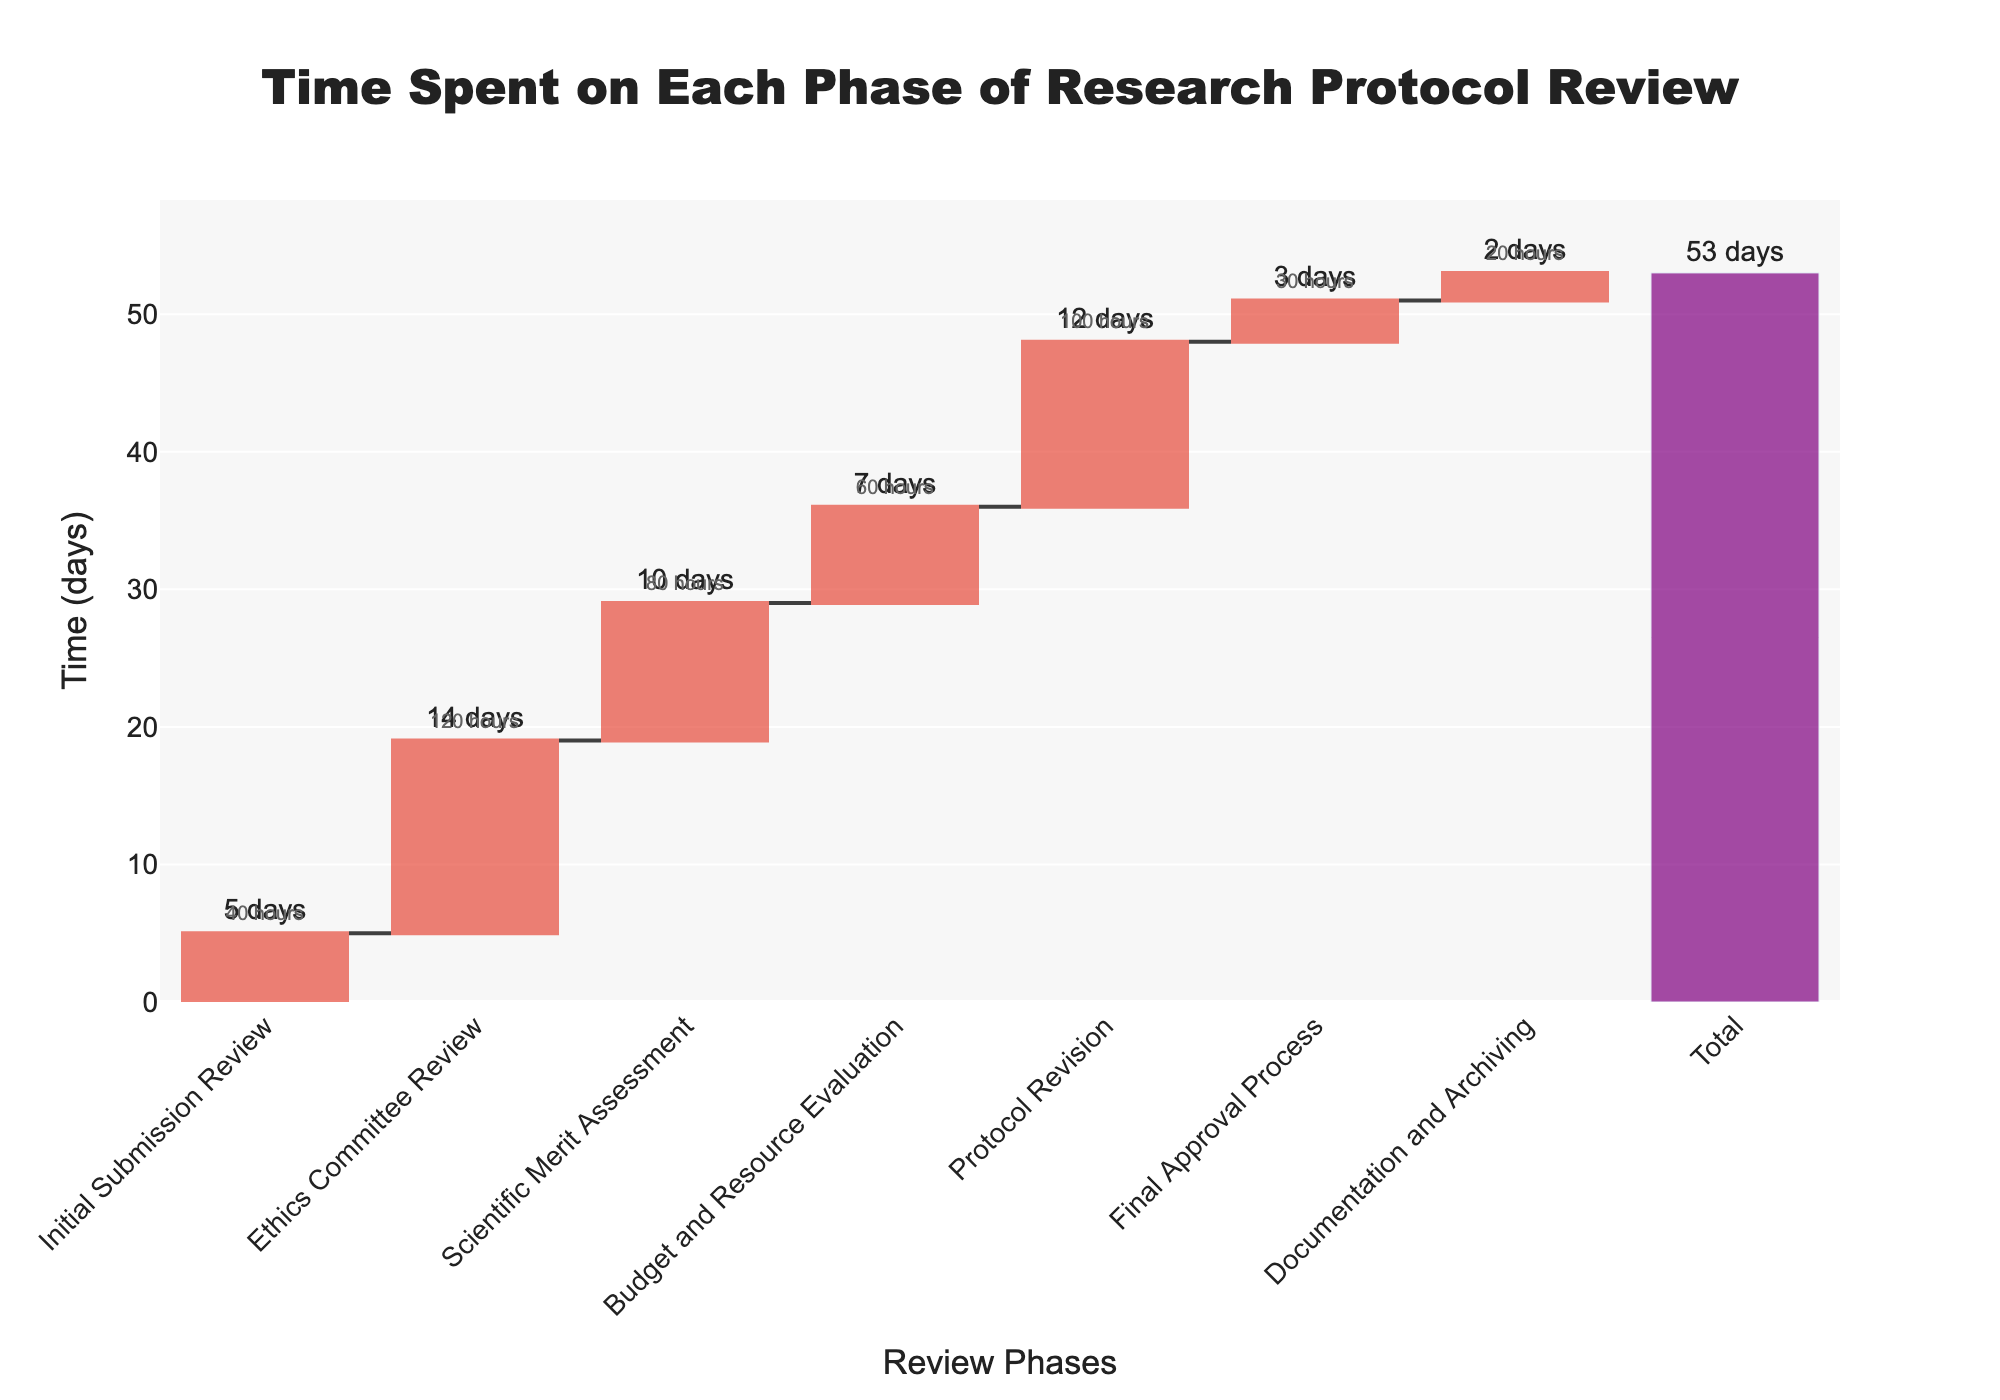what is the total time spent on the entire research protocol review process? The waterfall chart includes an extra bar at the end labeled "Total." This bar represents the sum of all times spent on individual phases. By looking at this bar, we can see that the total time spent is 53 days.
Answer: 53 days how much time is spent on the initial submission review phase? In the waterfall chart, each phase of the review process is labeled along the x-axis, and the corresponding time spent is indicated above each bar. For the "Initial Submission Review" phase, the label shows that 5 days were spent.
Answer: 5 days which phase required the highest number of staff hours? The hover text in the chart provides details about the time and the resources (staff hours) spent on each phase. By identifying the phase with the highest number of staff hours from the hover text, we find that the "Ethics Committee Review" phase required 120 staff hours.
Answer: Ethics Committee Review how much time was spent on the scientific merit assessment and final approval process combined? The y-values representing time for the "Scientific Merit Assessment" and "Final Approval Process" phases need to be summed. The Scientific Merit Assessment took 10 days, and the Final Approval Process took 3 days. So, 10 + 3 days equals 13 days.
Answer: 13 days which phase had the shortest duration? The shortest bar in the waterfall chart represents the phase with the least time spent. By looking at the chart, we see that the "Documentation and Archiving" phase has the shortest duration of 2 days.
Answer: Documentation and Archiving what is the average time spent per phase? To find the average time spent per phase, sum all the times and then divide by the number of phases. The total time is 53 days and there are 7 phases. So, 53 days / 7 phases = 7.57 days.
Answer: 7.57 days how much more time is spent on the ethics committee review compared to the budget and resource evaluation? The time for the Ethics Committee Review is 14 days, and for the Budget and Resource Evaluation, it is 7 days. The difference is 14 - 7 days = 7 days.
Answer: 7 days why might the protocol revision phase take longer than the initial submission review phase? Considering the waterfall chart shows that the "Protocol Revision" phase took 12 days, whereas the "Initial Submission Review" took only 5 days, the reason could be that revisions often involve responding to feedback, making corrections, and additional assessments, which can be more time-consuming compared to the initial submission review.
Answer: Revisions are usually more time-consuming due to feedback and corrections 